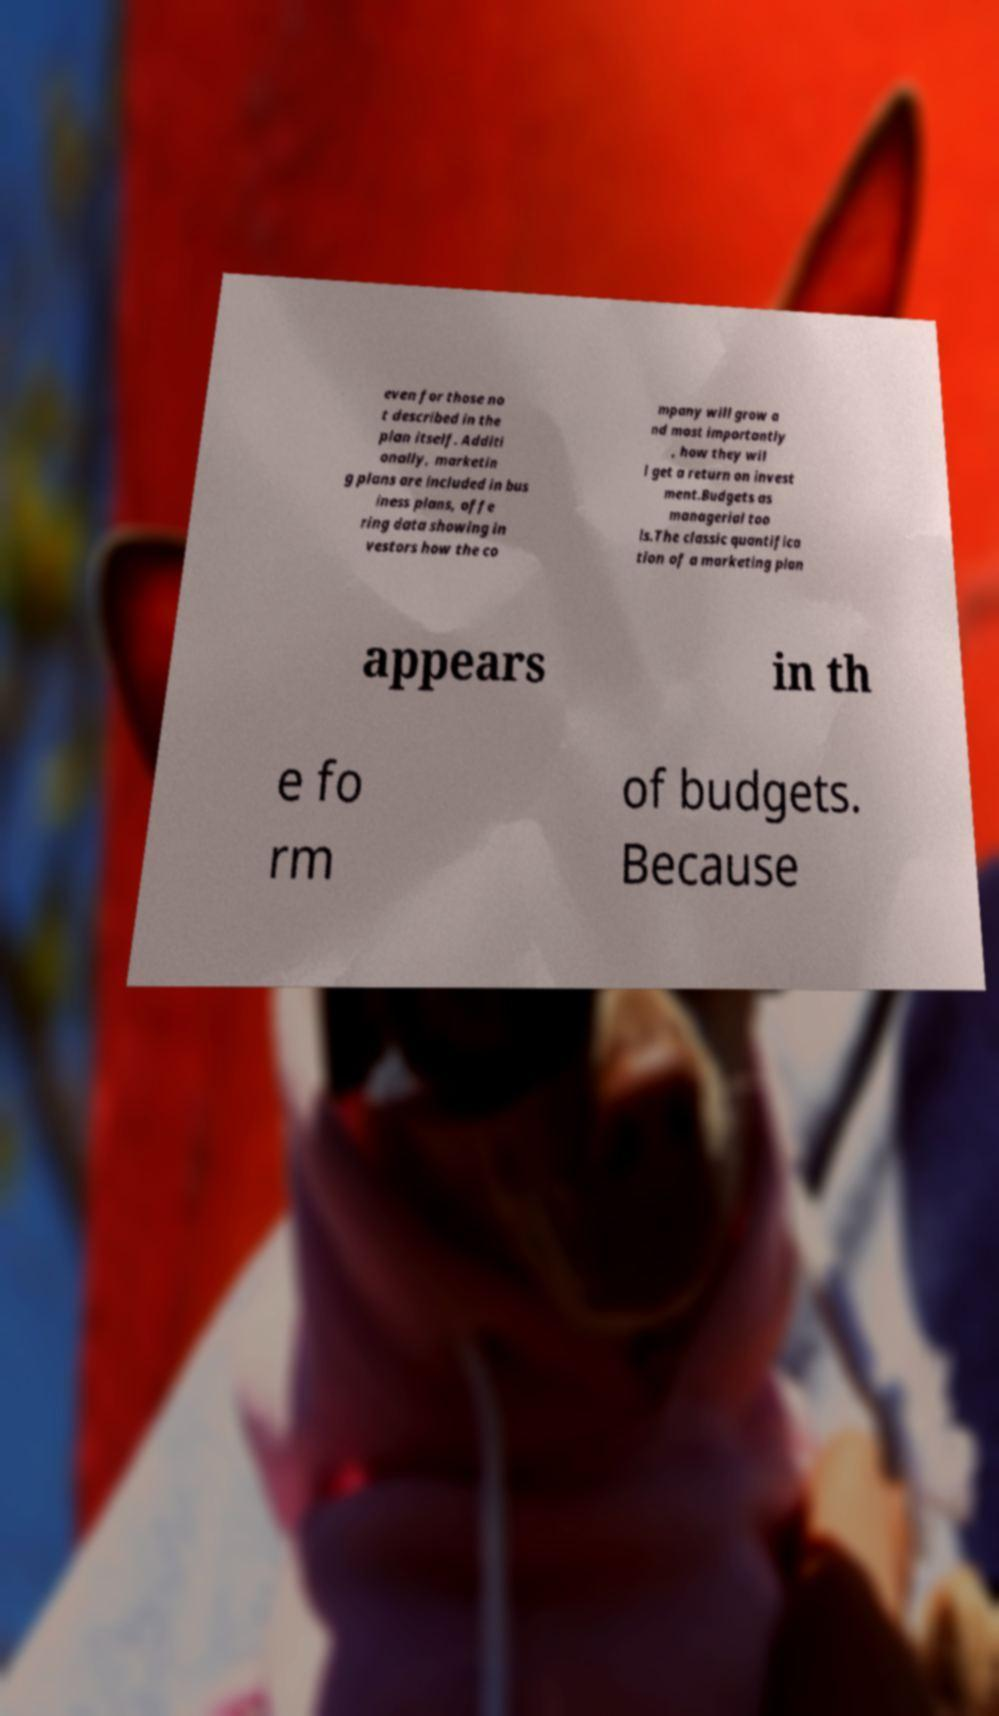I need the written content from this picture converted into text. Can you do that? even for those no t described in the plan itself. Additi onally, marketin g plans are included in bus iness plans, offe ring data showing in vestors how the co mpany will grow a nd most importantly , how they wil l get a return on invest ment.Budgets as managerial too ls.The classic quantifica tion of a marketing plan appears in th e fo rm of budgets. Because 